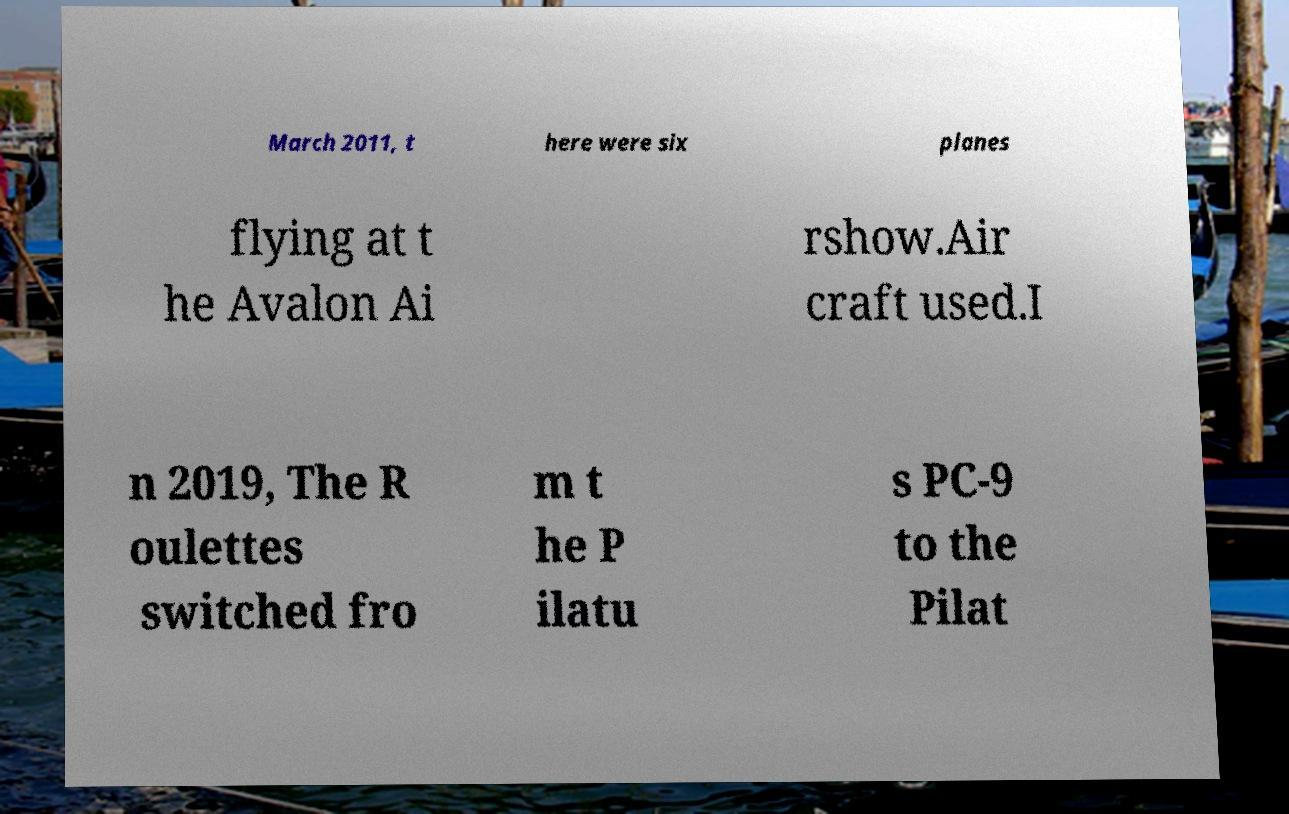For documentation purposes, I need the text within this image transcribed. Could you provide that? March 2011, t here were six planes flying at t he Avalon Ai rshow.Air craft used.I n 2019, The R oulettes switched fro m t he P ilatu s PC-9 to the Pilat 